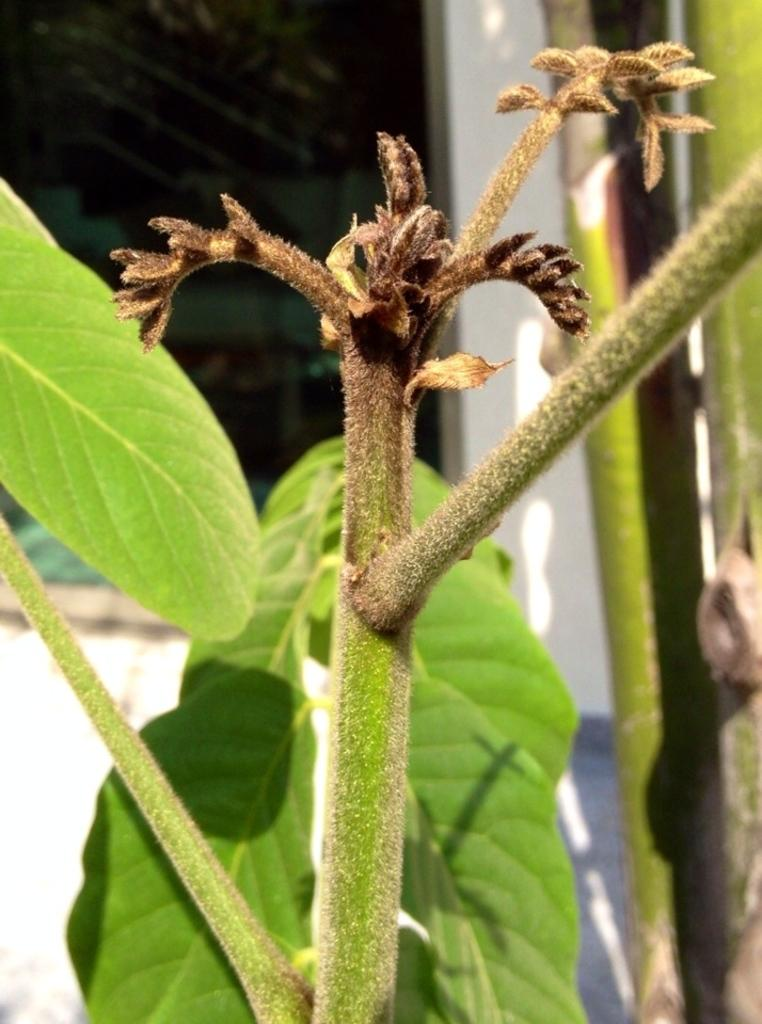What is in the foreground of the picture? There are leaves and a stem of a plant in the foreground of the picture. How would you describe the background of the image? The background of the image is blurred. What can be seen in the background of the picture? There is a window in the background of the image. What color is the wall in the background? The wall in the background is painted white. What type of current is flowing through the cabbage in the image? There is no cabbage present in the image, and no current is mentioned or visible. 